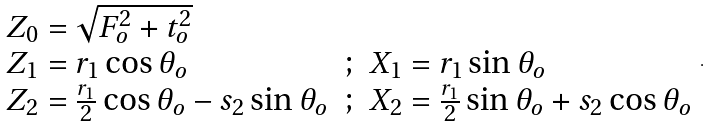Convert formula to latex. <formula><loc_0><loc_0><loc_500><loc_500>\begin{array} { l c l } Z _ { 0 } = \sqrt { F _ { o } ^ { 2 } + t _ { o } ^ { 2 } } & & \\ Z _ { 1 } = r _ { 1 } \cos \theta _ { o } & ; & X _ { 1 } = r _ { 1 } \sin \theta _ { o } \\ Z _ { 2 } = \frac { r _ { 1 } } { 2 } \cos \theta _ { o } - s _ { 2 } \sin \theta _ { o } & ; & X _ { 2 } = \frac { r _ { 1 } } { 2 } \sin \theta _ { o } + s _ { 2 } \cos \theta _ { o } \end{array} .</formula> 